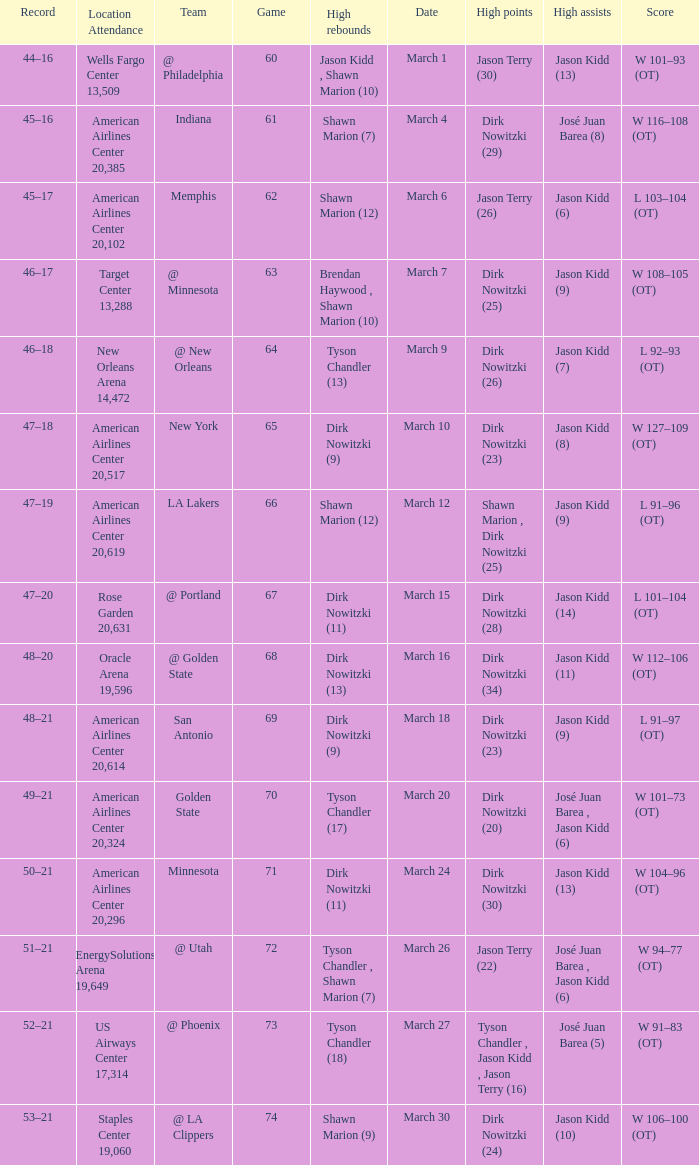Name the high points for march 30 Dirk Nowitzki (24). 